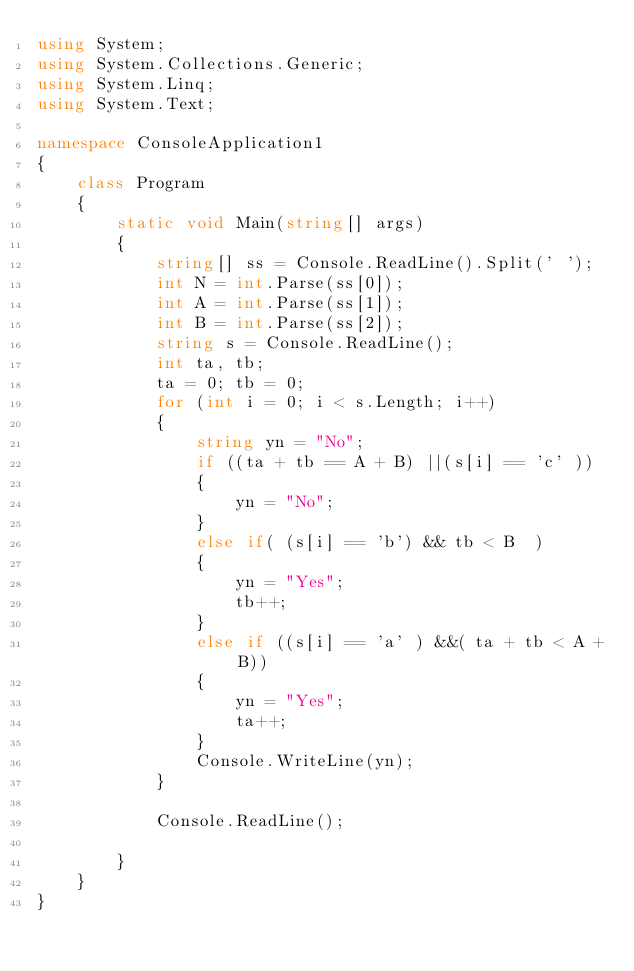<code> <loc_0><loc_0><loc_500><loc_500><_C#_>using System;
using System.Collections.Generic;
using System.Linq;
using System.Text;

namespace ConsoleApplication1
{
    class Program
    {
        static void Main(string[] args)
        {
            string[] ss = Console.ReadLine().Split(' ');
            int N = int.Parse(ss[0]);
            int A = int.Parse(ss[1]);
            int B = int.Parse(ss[2]);
            string s = Console.ReadLine();
            int ta, tb;
            ta = 0; tb = 0;
            for (int i = 0; i < s.Length; i++)
            {
                string yn = "No";                
                if ((ta + tb == A + B) ||(s[i] == 'c' ))
                {
                    yn = "No";
                }
                else if( (s[i] == 'b') && tb < B  ) 
                {
                    yn = "Yes";
                    tb++;
                }
                else if ((s[i] == 'a' ) &&( ta + tb < A + B))
                {
                    yn = "Yes";
                    ta++;
                }
                Console.WriteLine(yn);
            }

            Console.ReadLine();

        }
    }
}
</code> 